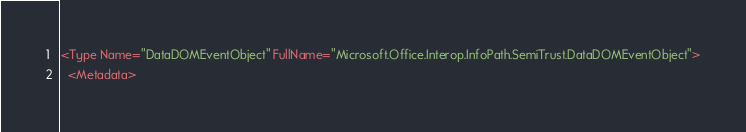<code> <loc_0><loc_0><loc_500><loc_500><_XML_><Type Name="DataDOMEventObject" FullName="Microsoft.Office.Interop.InfoPath.SemiTrust.DataDOMEventObject">
  <Metadata></code> 